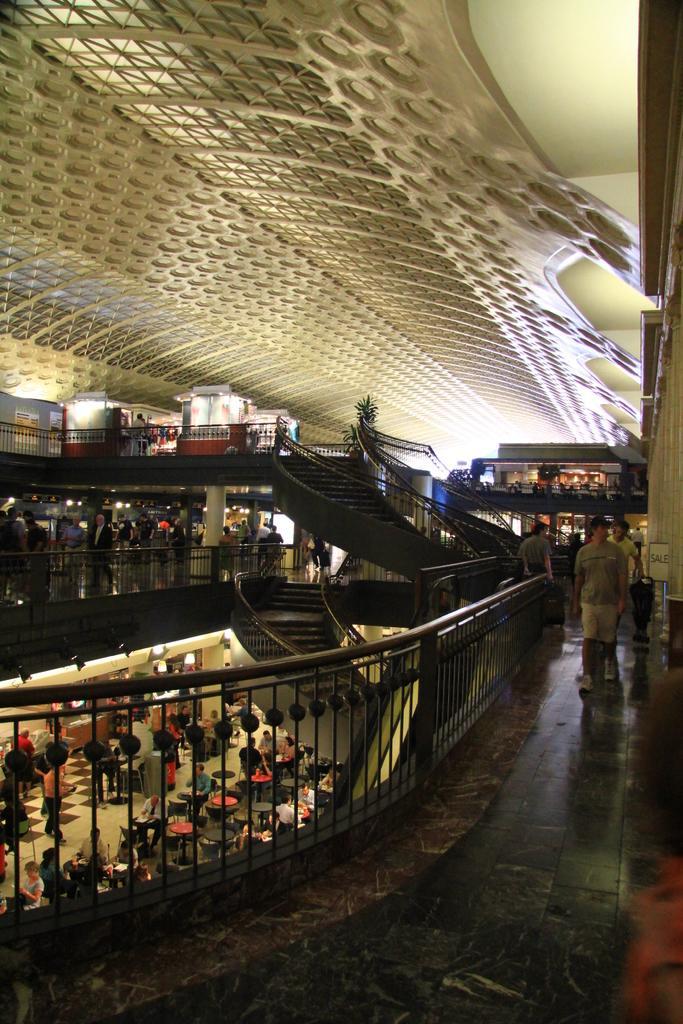Please provide a concise description of this image. It looks like an inside view of the mall. Here we can see stairs, railings, plant, stalls. In this image, we can see few people. Top of the image, there is a roof. 